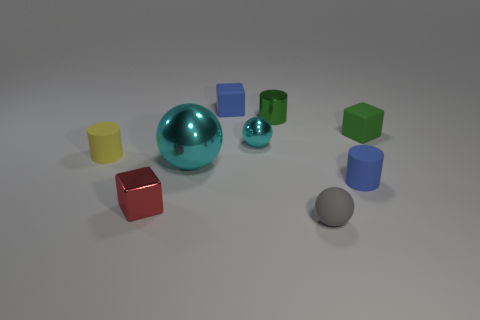Subtract all tiny matte cylinders. How many cylinders are left? 1 Subtract all brown cylinders. How many cyan balls are left? 2 Add 1 matte objects. How many objects exist? 10 Subtract 1 blocks. How many blocks are left? 2 Subtract all spheres. How many objects are left? 6 Subtract all cyan cylinders. Subtract all yellow cubes. How many cylinders are left? 3 Subtract all matte cylinders. Subtract all tiny blue matte objects. How many objects are left? 5 Add 8 small yellow things. How many small yellow things are left? 9 Add 4 gray rubber things. How many gray rubber things exist? 5 Subtract 0 brown balls. How many objects are left? 9 